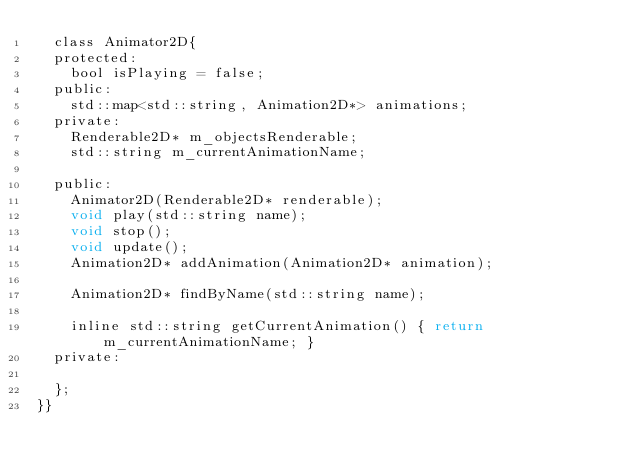<code> <loc_0><loc_0><loc_500><loc_500><_C_>	class Animator2D{
	protected:
		bool isPlaying = false;
	public:
		std::map<std::string, Animation2D*> animations;
	private:
		Renderable2D* m_objectsRenderable;
		std::string m_currentAnimationName;
		
	public:
		Animator2D(Renderable2D* renderable);
		void play(std::string name);
		void stop();
		void update();
		Animation2D* addAnimation(Animation2D* animation);

		Animation2D* findByName(std::string name);

		inline std::string getCurrentAnimation() { return m_currentAnimationName; }
	private:

	};
}}</code> 